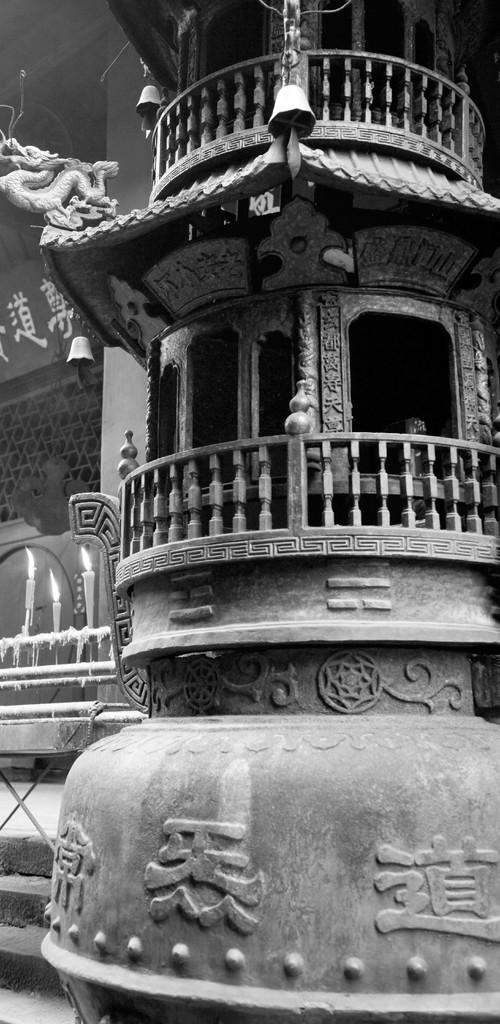What type of structure is visible on the right side of the image? There is an architecture on the right side of the image. What can be found on the left side of the image? There are candles and pipes on the left side of the image. What is the purpose of the net wall on the left side of the image? The purpose of the net wall is not specified in the image, but it could be used for various purposes such as decoration or safety. What type of country is depicted in the image? There is no country depicted in the image; it features architecture, candles, pipes, and a net wall. How does the paste help in the image? There is no paste present in the image, so it cannot help in any way. 